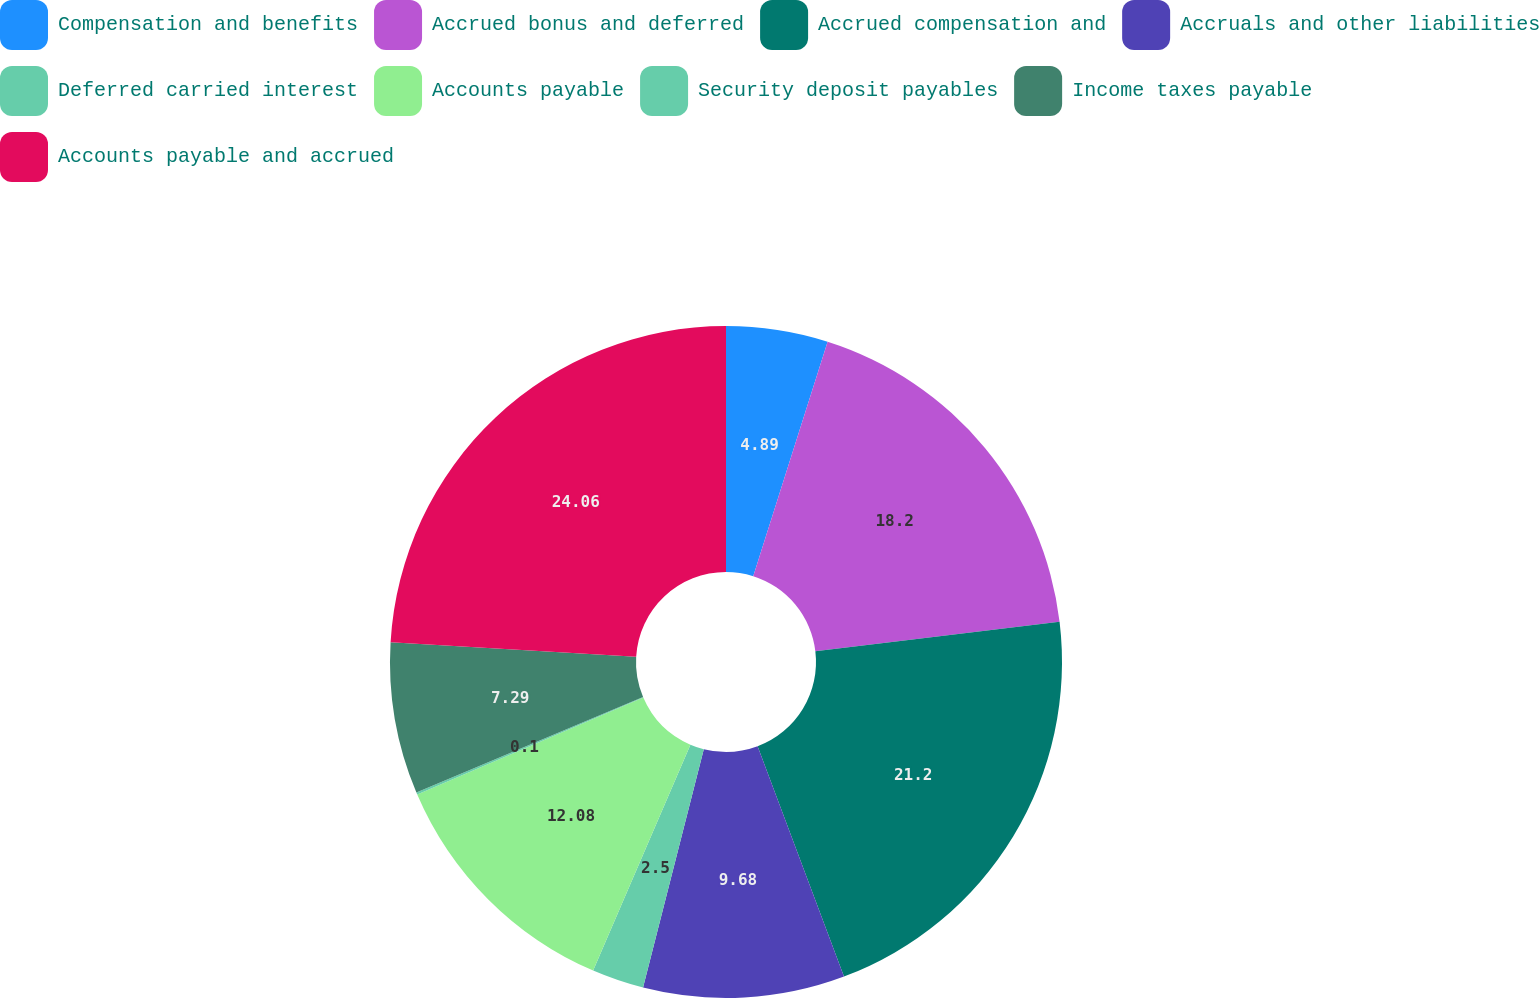<chart> <loc_0><loc_0><loc_500><loc_500><pie_chart><fcel>Compensation and benefits<fcel>Accrued bonus and deferred<fcel>Accrued compensation and<fcel>Accruals and other liabilities<fcel>Deferred carried interest<fcel>Accounts payable<fcel>Security deposit payables<fcel>Income taxes payable<fcel>Accounts payable and accrued<nl><fcel>4.89%<fcel>18.2%<fcel>21.2%<fcel>9.68%<fcel>2.5%<fcel>12.08%<fcel>0.1%<fcel>7.29%<fcel>24.06%<nl></chart> 